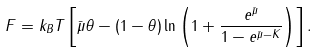<formula> <loc_0><loc_0><loc_500><loc_500>F = k _ { B } T \left [ \bar { \mu } \theta - ( 1 - \theta ) \ln \left ( 1 + \frac { e ^ { \bar { \mu } } } { 1 - e ^ { \bar { \mu } - K } } \right ) \right ] .</formula> 